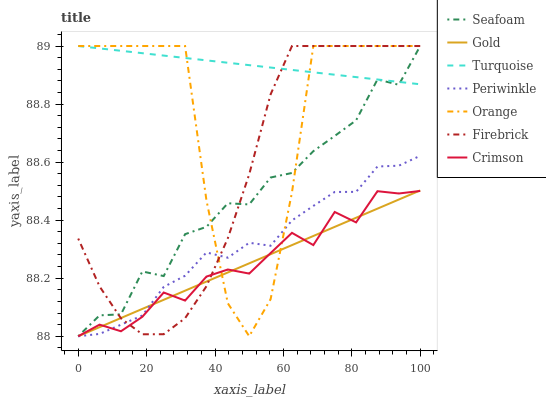Does Firebrick have the minimum area under the curve?
Answer yes or no. No. Does Firebrick have the maximum area under the curve?
Answer yes or no. No. Is Gold the smoothest?
Answer yes or no. No. Is Gold the roughest?
Answer yes or no. No. Does Firebrick have the lowest value?
Answer yes or no. No. Does Gold have the highest value?
Answer yes or no. No. Is Crimson less than Turquoise?
Answer yes or no. Yes. Is Turquoise greater than Periwinkle?
Answer yes or no. Yes. Does Crimson intersect Turquoise?
Answer yes or no. No. 